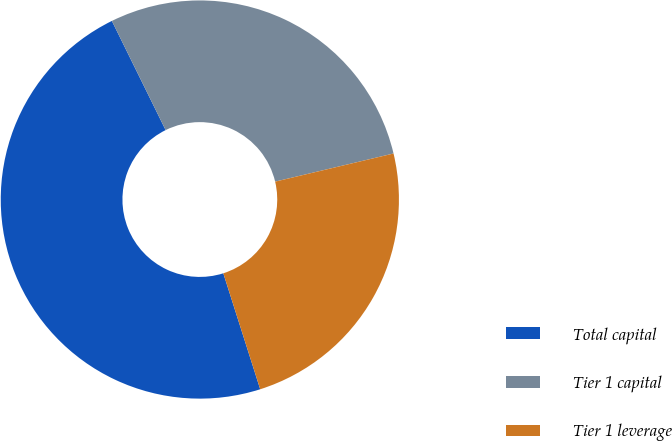Convert chart. <chart><loc_0><loc_0><loc_500><loc_500><pie_chart><fcel>Total capital<fcel>Tier 1 capital<fcel>Tier 1 leverage<nl><fcel>47.62%<fcel>28.57%<fcel>23.81%<nl></chart> 